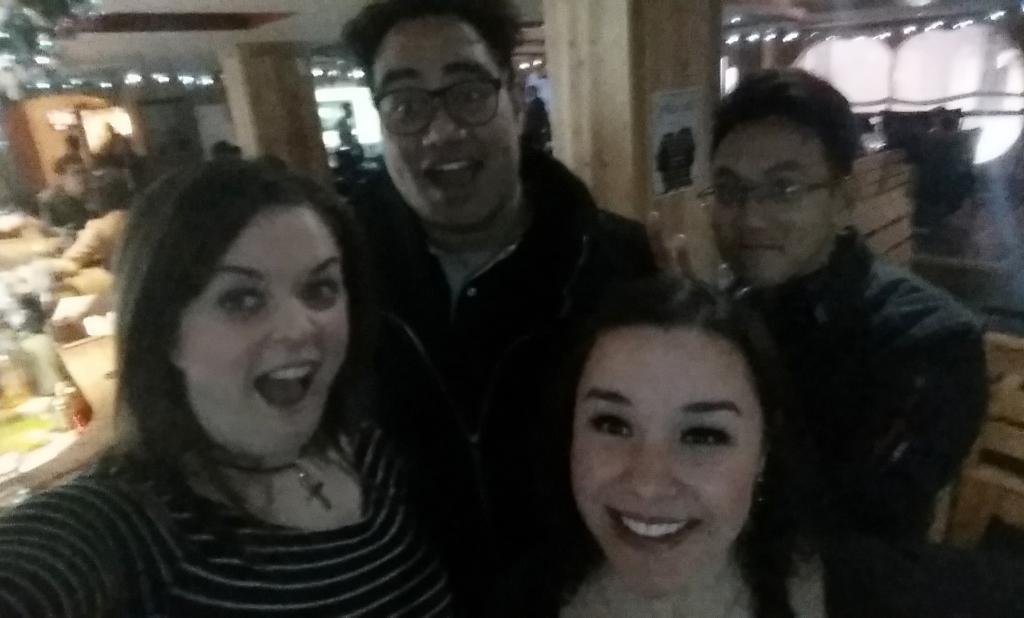In one or two sentences, can you explain what this image depicts? In this picture we can see some boys and girls standing in the front, smiling and giving a pose into the camera. Behind there is a restaurant view with some table and chairs. 